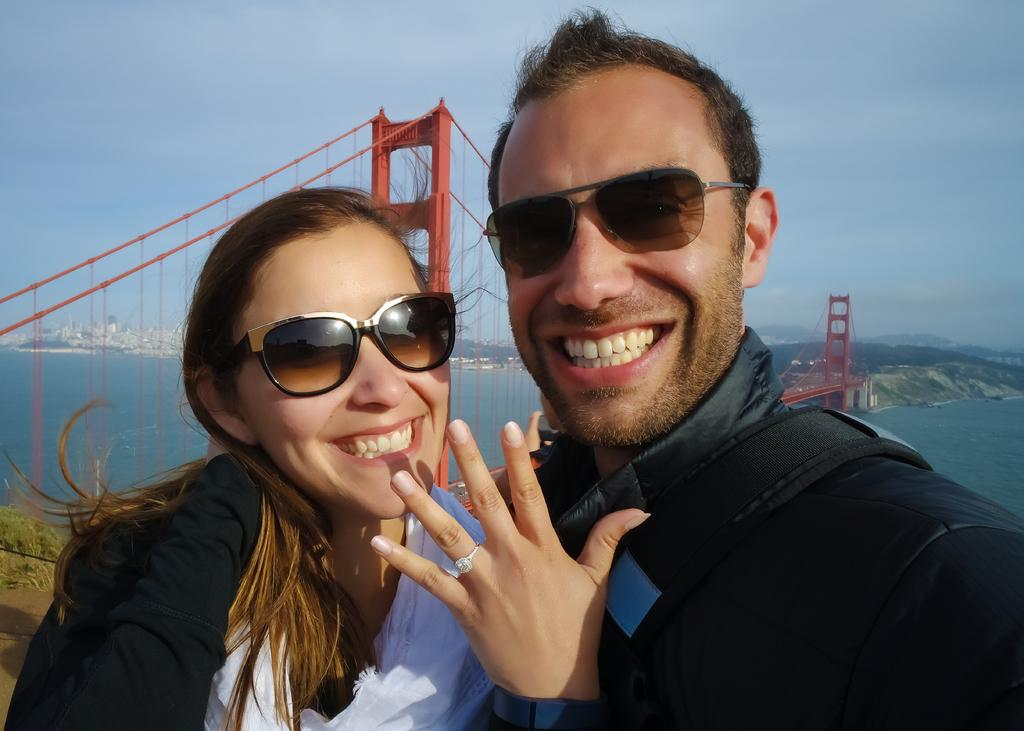How many people are in the image? There are two people standing and smiling in the image. What are the people in the image doing? The people are standing and smiling. What can be seen in the background of the image? There is a red color bridge, water, buildings, and the sky in white and blue color visible in the background. What type of star can be seen guiding the people in the image? There is no star present in the image, and the people are not being guided by any celestial object. 